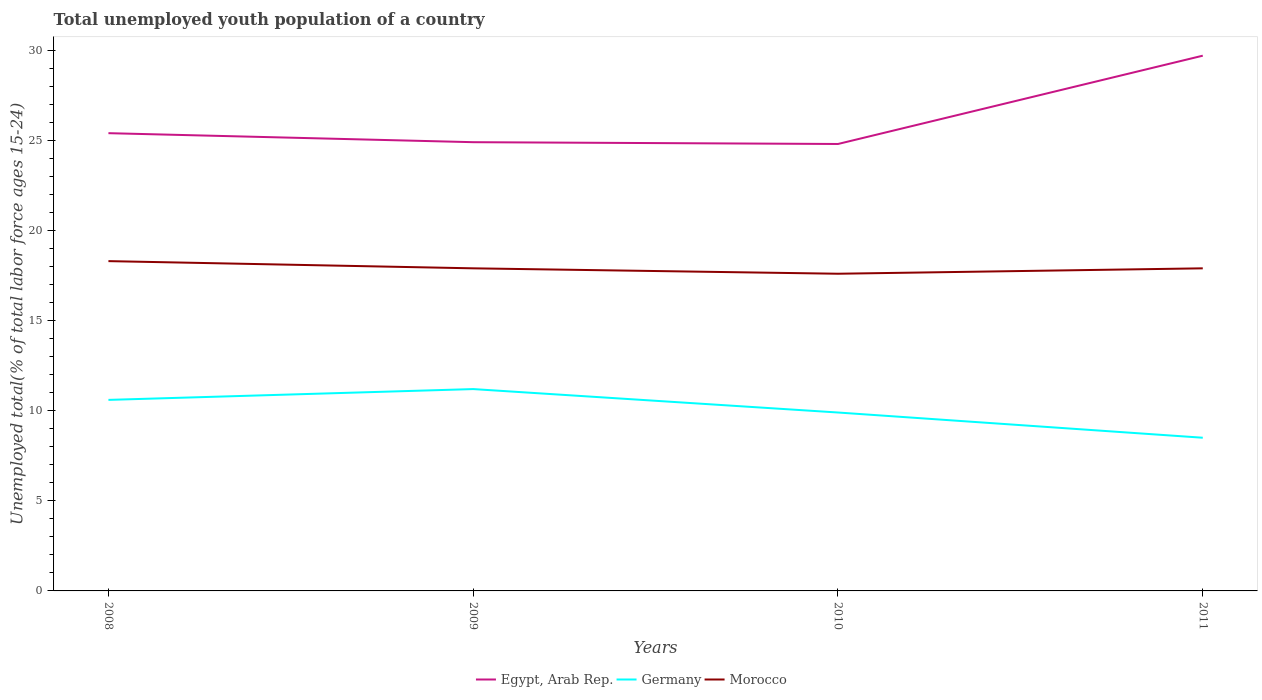How many different coloured lines are there?
Ensure brevity in your answer.  3. Does the line corresponding to Egypt, Arab Rep. intersect with the line corresponding to Germany?
Provide a succinct answer. No. Across all years, what is the maximum percentage of total unemployed youth population of a country in Morocco?
Make the answer very short. 17.6. In which year was the percentage of total unemployed youth population of a country in Egypt, Arab Rep. maximum?
Provide a succinct answer. 2010. What is the total percentage of total unemployed youth population of a country in Egypt, Arab Rep. in the graph?
Provide a succinct answer. 0.1. What is the difference between the highest and the second highest percentage of total unemployed youth population of a country in Germany?
Keep it short and to the point. 2.7. What is the difference between two consecutive major ticks on the Y-axis?
Offer a terse response. 5. How many legend labels are there?
Offer a terse response. 3. What is the title of the graph?
Your answer should be very brief. Total unemployed youth population of a country. Does "Dominica" appear as one of the legend labels in the graph?
Offer a very short reply. No. What is the label or title of the X-axis?
Give a very brief answer. Years. What is the label or title of the Y-axis?
Make the answer very short. Unemployed total(% of total labor force ages 15-24). What is the Unemployed total(% of total labor force ages 15-24) of Egypt, Arab Rep. in 2008?
Provide a succinct answer. 25.4. What is the Unemployed total(% of total labor force ages 15-24) in Germany in 2008?
Give a very brief answer. 10.6. What is the Unemployed total(% of total labor force ages 15-24) in Morocco in 2008?
Provide a succinct answer. 18.3. What is the Unemployed total(% of total labor force ages 15-24) in Egypt, Arab Rep. in 2009?
Keep it short and to the point. 24.9. What is the Unemployed total(% of total labor force ages 15-24) of Germany in 2009?
Provide a short and direct response. 11.2. What is the Unemployed total(% of total labor force ages 15-24) of Morocco in 2009?
Offer a terse response. 17.9. What is the Unemployed total(% of total labor force ages 15-24) in Egypt, Arab Rep. in 2010?
Keep it short and to the point. 24.8. What is the Unemployed total(% of total labor force ages 15-24) in Germany in 2010?
Provide a short and direct response. 9.9. What is the Unemployed total(% of total labor force ages 15-24) in Morocco in 2010?
Provide a short and direct response. 17.6. What is the Unemployed total(% of total labor force ages 15-24) of Egypt, Arab Rep. in 2011?
Provide a short and direct response. 29.7. What is the Unemployed total(% of total labor force ages 15-24) of Morocco in 2011?
Keep it short and to the point. 17.9. Across all years, what is the maximum Unemployed total(% of total labor force ages 15-24) of Egypt, Arab Rep.?
Keep it short and to the point. 29.7. Across all years, what is the maximum Unemployed total(% of total labor force ages 15-24) in Germany?
Offer a terse response. 11.2. Across all years, what is the maximum Unemployed total(% of total labor force ages 15-24) in Morocco?
Offer a terse response. 18.3. Across all years, what is the minimum Unemployed total(% of total labor force ages 15-24) in Egypt, Arab Rep.?
Make the answer very short. 24.8. Across all years, what is the minimum Unemployed total(% of total labor force ages 15-24) of Morocco?
Your answer should be very brief. 17.6. What is the total Unemployed total(% of total labor force ages 15-24) in Egypt, Arab Rep. in the graph?
Your response must be concise. 104.8. What is the total Unemployed total(% of total labor force ages 15-24) in Germany in the graph?
Your answer should be compact. 40.2. What is the total Unemployed total(% of total labor force ages 15-24) in Morocco in the graph?
Provide a succinct answer. 71.7. What is the difference between the Unemployed total(% of total labor force ages 15-24) in Egypt, Arab Rep. in 2008 and that in 2010?
Offer a terse response. 0.6. What is the difference between the Unemployed total(% of total labor force ages 15-24) of Morocco in 2008 and that in 2010?
Keep it short and to the point. 0.7. What is the difference between the Unemployed total(% of total labor force ages 15-24) in Egypt, Arab Rep. in 2008 and that in 2011?
Your answer should be compact. -4.3. What is the difference between the Unemployed total(% of total labor force ages 15-24) of Egypt, Arab Rep. in 2009 and that in 2010?
Your response must be concise. 0.1. What is the difference between the Unemployed total(% of total labor force ages 15-24) of Morocco in 2009 and that in 2010?
Provide a succinct answer. 0.3. What is the difference between the Unemployed total(% of total labor force ages 15-24) in Morocco in 2009 and that in 2011?
Ensure brevity in your answer.  0. What is the difference between the Unemployed total(% of total labor force ages 15-24) in Egypt, Arab Rep. in 2010 and that in 2011?
Your answer should be compact. -4.9. What is the difference between the Unemployed total(% of total labor force ages 15-24) of Germany in 2010 and that in 2011?
Provide a succinct answer. 1.4. What is the difference between the Unemployed total(% of total labor force ages 15-24) in Egypt, Arab Rep. in 2008 and the Unemployed total(% of total labor force ages 15-24) in Morocco in 2009?
Provide a succinct answer. 7.5. What is the difference between the Unemployed total(% of total labor force ages 15-24) in Germany in 2008 and the Unemployed total(% of total labor force ages 15-24) in Morocco in 2010?
Your answer should be very brief. -7. What is the difference between the Unemployed total(% of total labor force ages 15-24) of Egypt, Arab Rep. in 2008 and the Unemployed total(% of total labor force ages 15-24) of Germany in 2011?
Provide a short and direct response. 16.9. What is the difference between the Unemployed total(% of total labor force ages 15-24) of Egypt, Arab Rep. in 2008 and the Unemployed total(% of total labor force ages 15-24) of Morocco in 2011?
Make the answer very short. 7.5. What is the difference between the Unemployed total(% of total labor force ages 15-24) of Germany in 2008 and the Unemployed total(% of total labor force ages 15-24) of Morocco in 2011?
Offer a very short reply. -7.3. What is the difference between the Unemployed total(% of total labor force ages 15-24) of Egypt, Arab Rep. in 2009 and the Unemployed total(% of total labor force ages 15-24) of Germany in 2010?
Keep it short and to the point. 15. What is the difference between the Unemployed total(% of total labor force ages 15-24) of Germany in 2009 and the Unemployed total(% of total labor force ages 15-24) of Morocco in 2010?
Provide a short and direct response. -6.4. What is the difference between the Unemployed total(% of total labor force ages 15-24) in Egypt, Arab Rep. in 2009 and the Unemployed total(% of total labor force ages 15-24) in Morocco in 2011?
Your response must be concise. 7. What is the difference between the Unemployed total(% of total labor force ages 15-24) of Germany in 2009 and the Unemployed total(% of total labor force ages 15-24) of Morocco in 2011?
Give a very brief answer. -6.7. What is the difference between the Unemployed total(% of total labor force ages 15-24) of Egypt, Arab Rep. in 2010 and the Unemployed total(% of total labor force ages 15-24) of Germany in 2011?
Provide a succinct answer. 16.3. What is the difference between the Unemployed total(% of total labor force ages 15-24) in Egypt, Arab Rep. in 2010 and the Unemployed total(% of total labor force ages 15-24) in Morocco in 2011?
Offer a terse response. 6.9. What is the average Unemployed total(% of total labor force ages 15-24) of Egypt, Arab Rep. per year?
Keep it short and to the point. 26.2. What is the average Unemployed total(% of total labor force ages 15-24) of Germany per year?
Your answer should be compact. 10.05. What is the average Unemployed total(% of total labor force ages 15-24) of Morocco per year?
Provide a succinct answer. 17.93. In the year 2008, what is the difference between the Unemployed total(% of total labor force ages 15-24) in Egypt, Arab Rep. and Unemployed total(% of total labor force ages 15-24) in Germany?
Provide a succinct answer. 14.8. In the year 2008, what is the difference between the Unemployed total(% of total labor force ages 15-24) in Egypt, Arab Rep. and Unemployed total(% of total labor force ages 15-24) in Morocco?
Your answer should be very brief. 7.1. In the year 2009, what is the difference between the Unemployed total(% of total labor force ages 15-24) of Egypt, Arab Rep. and Unemployed total(% of total labor force ages 15-24) of Germany?
Provide a short and direct response. 13.7. In the year 2009, what is the difference between the Unemployed total(% of total labor force ages 15-24) of Egypt, Arab Rep. and Unemployed total(% of total labor force ages 15-24) of Morocco?
Your answer should be very brief. 7. In the year 2009, what is the difference between the Unemployed total(% of total labor force ages 15-24) in Germany and Unemployed total(% of total labor force ages 15-24) in Morocco?
Offer a very short reply. -6.7. In the year 2010, what is the difference between the Unemployed total(% of total labor force ages 15-24) of Egypt, Arab Rep. and Unemployed total(% of total labor force ages 15-24) of Germany?
Your answer should be very brief. 14.9. In the year 2011, what is the difference between the Unemployed total(% of total labor force ages 15-24) of Egypt, Arab Rep. and Unemployed total(% of total labor force ages 15-24) of Germany?
Provide a short and direct response. 21.2. In the year 2011, what is the difference between the Unemployed total(% of total labor force ages 15-24) in Egypt, Arab Rep. and Unemployed total(% of total labor force ages 15-24) in Morocco?
Ensure brevity in your answer.  11.8. In the year 2011, what is the difference between the Unemployed total(% of total labor force ages 15-24) of Germany and Unemployed total(% of total labor force ages 15-24) of Morocco?
Provide a short and direct response. -9.4. What is the ratio of the Unemployed total(% of total labor force ages 15-24) in Egypt, Arab Rep. in 2008 to that in 2009?
Give a very brief answer. 1.02. What is the ratio of the Unemployed total(% of total labor force ages 15-24) of Germany in 2008 to that in 2009?
Provide a short and direct response. 0.95. What is the ratio of the Unemployed total(% of total labor force ages 15-24) of Morocco in 2008 to that in 2009?
Your answer should be very brief. 1.02. What is the ratio of the Unemployed total(% of total labor force ages 15-24) in Egypt, Arab Rep. in 2008 to that in 2010?
Give a very brief answer. 1.02. What is the ratio of the Unemployed total(% of total labor force ages 15-24) of Germany in 2008 to that in 2010?
Keep it short and to the point. 1.07. What is the ratio of the Unemployed total(% of total labor force ages 15-24) in Morocco in 2008 to that in 2010?
Make the answer very short. 1.04. What is the ratio of the Unemployed total(% of total labor force ages 15-24) in Egypt, Arab Rep. in 2008 to that in 2011?
Keep it short and to the point. 0.86. What is the ratio of the Unemployed total(% of total labor force ages 15-24) in Germany in 2008 to that in 2011?
Your answer should be compact. 1.25. What is the ratio of the Unemployed total(% of total labor force ages 15-24) in Morocco in 2008 to that in 2011?
Ensure brevity in your answer.  1.02. What is the ratio of the Unemployed total(% of total labor force ages 15-24) in Egypt, Arab Rep. in 2009 to that in 2010?
Your response must be concise. 1. What is the ratio of the Unemployed total(% of total labor force ages 15-24) in Germany in 2009 to that in 2010?
Make the answer very short. 1.13. What is the ratio of the Unemployed total(% of total labor force ages 15-24) of Egypt, Arab Rep. in 2009 to that in 2011?
Make the answer very short. 0.84. What is the ratio of the Unemployed total(% of total labor force ages 15-24) in Germany in 2009 to that in 2011?
Provide a short and direct response. 1.32. What is the ratio of the Unemployed total(% of total labor force ages 15-24) in Morocco in 2009 to that in 2011?
Your response must be concise. 1. What is the ratio of the Unemployed total(% of total labor force ages 15-24) of Egypt, Arab Rep. in 2010 to that in 2011?
Ensure brevity in your answer.  0.83. What is the ratio of the Unemployed total(% of total labor force ages 15-24) in Germany in 2010 to that in 2011?
Keep it short and to the point. 1.16. What is the ratio of the Unemployed total(% of total labor force ages 15-24) of Morocco in 2010 to that in 2011?
Offer a terse response. 0.98. What is the difference between the highest and the second highest Unemployed total(% of total labor force ages 15-24) in Egypt, Arab Rep.?
Offer a very short reply. 4.3. What is the difference between the highest and the second highest Unemployed total(% of total labor force ages 15-24) in Germany?
Offer a terse response. 0.6. What is the difference between the highest and the second highest Unemployed total(% of total labor force ages 15-24) of Morocco?
Give a very brief answer. 0.4. What is the difference between the highest and the lowest Unemployed total(% of total labor force ages 15-24) in Egypt, Arab Rep.?
Your answer should be very brief. 4.9. 